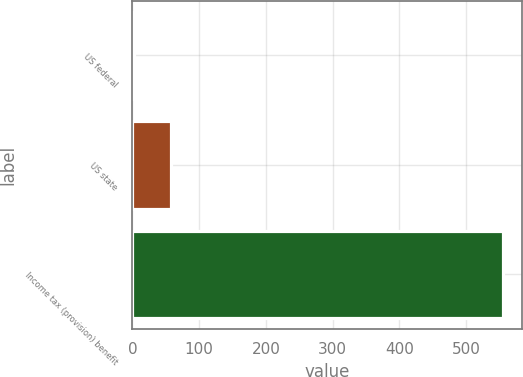Convert chart. <chart><loc_0><loc_0><loc_500><loc_500><bar_chart><fcel>US federal<fcel>US state<fcel>Income tax (provision) benefit<nl><fcel>3<fcel>58.3<fcel>556<nl></chart> 